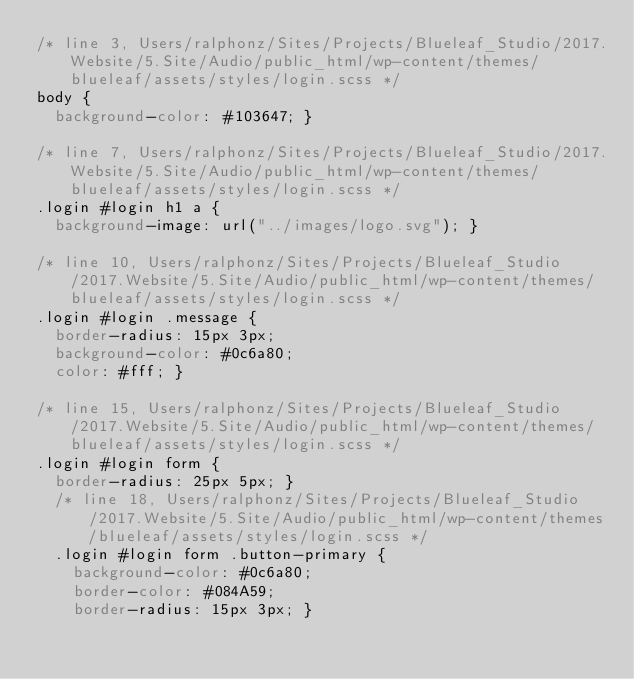Convert code to text. <code><loc_0><loc_0><loc_500><loc_500><_CSS_>/* line 3, Users/ralphonz/Sites/Projects/Blueleaf_Studio/2017.Website/5.Site/Audio/public_html/wp-content/themes/blueleaf/assets/styles/login.scss */
body {
  background-color: #103647; }

/* line 7, Users/ralphonz/Sites/Projects/Blueleaf_Studio/2017.Website/5.Site/Audio/public_html/wp-content/themes/blueleaf/assets/styles/login.scss */
.login #login h1 a {
  background-image: url("../images/logo.svg"); }

/* line 10, Users/ralphonz/Sites/Projects/Blueleaf_Studio/2017.Website/5.Site/Audio/public_html/wp-content/themes/blueleaf/assets/styles/login.scss */
.login #login .message {
  border-radius: 15px 3px;
  background-color: #0c6a80;
  color: #fff; }

/* line 15, Users/ralphonz/Sites/Projects/Blueleaf_Studio/2017.Website/5.Site/Audio/public_html/wp-content/themes/blueleaf/assets/styles/login.scss */
.login #login form {
  border-radius: 25px 5px; }
  /* line 18, Users/ralphonz/Sites/Projects/Blueleaf_Studio/2017.Website/5.Site/Audio/public_html/wp-content/themes/blueleaf/assets/styles/login.scss */
  .login #login form .button-primary {
    background-color: #0c6a80;
    border-color: #084A59;
    border-radius: 15px 3px; }</code> 